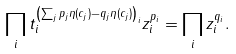Convert formula to latex. <formula><loc_0><loc_0><loc_500><loc_500>\prod _ { i } t _ { i } ^ { \left ( \sum _ { j } p _ { j } \eta ( c _ { j } ) - q _ { j } \eta ( c _ { j } ) \right ) _ { i } } z _ { i } ^ { p _ { i } } = \prod _ { i } z _ { i } ^ { q _ { i } } .</formula> 